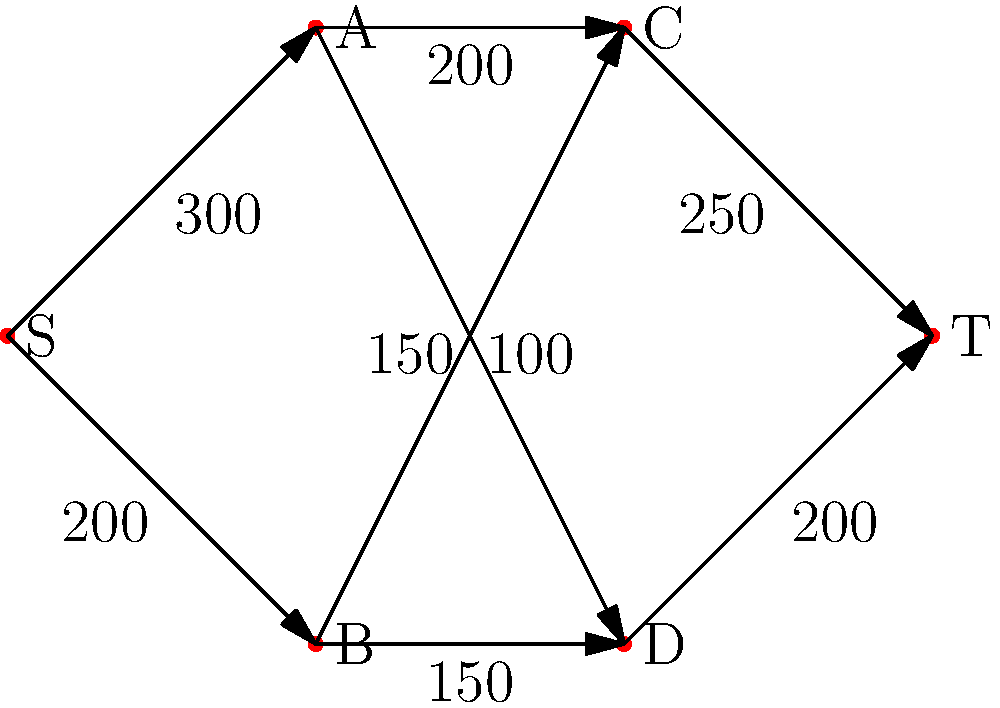At a Jason Momoa fan convention, organizers need to manage crowd flow through different areas. The graph represents the convention layout, where S is the entrance, T is the exit, and A, B, C, and D are different event spaces. Edge weights indicate the maximum number of fans that can move between areas per hour. What is the maximum number of fans that can flow through the convention from entrance to exit per hour? To solve this maximum flow problem, we'll use the Ford-Fulkerson algorithm:

1. Initialize flow to 0 for all edges.
2. Find an augmenting path from S to T:
   a. S -> A -> C -> T (min capacity 200)
   b. Increase flow by 200
   c. Residual graph: decrease S->A, A->C, C->T by 200; increase reverse edges

3. Find another augmenting path:
   a. S -> B -> D -> T (min capacity 200)
   b. Increase flow by 200
   c. Update residual graph

4. Find another augmenting path:
   a. S -> A -> D -> T (min capacity 50)
   b. Increase flow by 50
   c. Update residual graph

5. No more augmenting paths exist

6. Sum the flows:
   200 (S->A->C->T) + 200 (S->B->D->T) + 50 (S->A->D->T) = 450

Therefore, the maximum flow through the convention is 450 fans per hour.
Answer: 450 fans per hour 